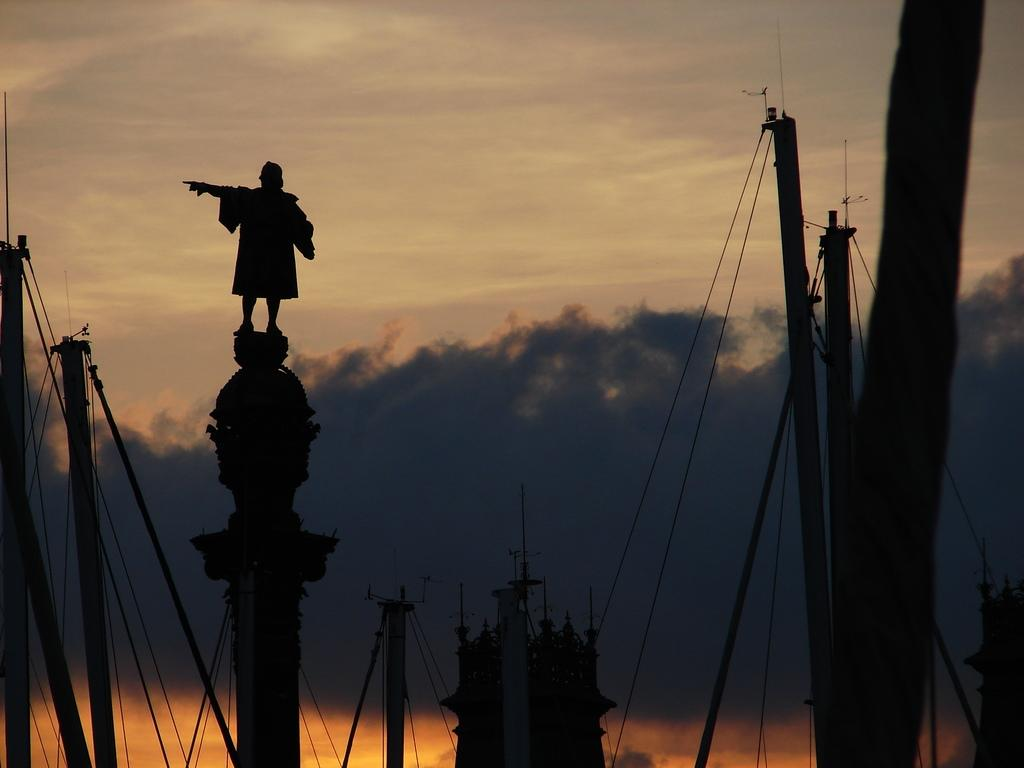What is located in the center of the image? There are poles, wires, a statue, and other objects in the center of the image. Can you describe the statue in the image? There is a statue in the center of the image, but its specific details are not mentioned in the facts. What is visible in the background of the image? The sky is visible in the background of the image, and clouds are present. How many legs does the locket have in the image? There is no locket present in the image. What step is the statue taking in the image? The statue is not shown taking any steps in the image; it is stationary. 